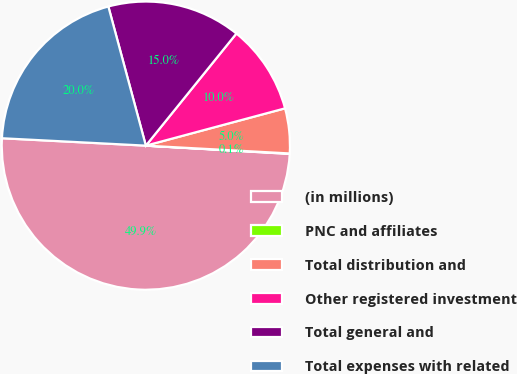Convert chart to OTSL. <chart><loc_0><loc_0><loc_500><loc_500><pie_chart><fcel>(in millions)<fcel>PNC and affiliates<fcel>Total distribution and<fcel>Other registered investment<fcel>Total general and<fcel>Total expenses with related<nl><fcel>49.9%<fcel>0.05%<fcel>5.03%<fcel>10.02%<fcel>15.0%<fcel>19.99%<nl></chart> 